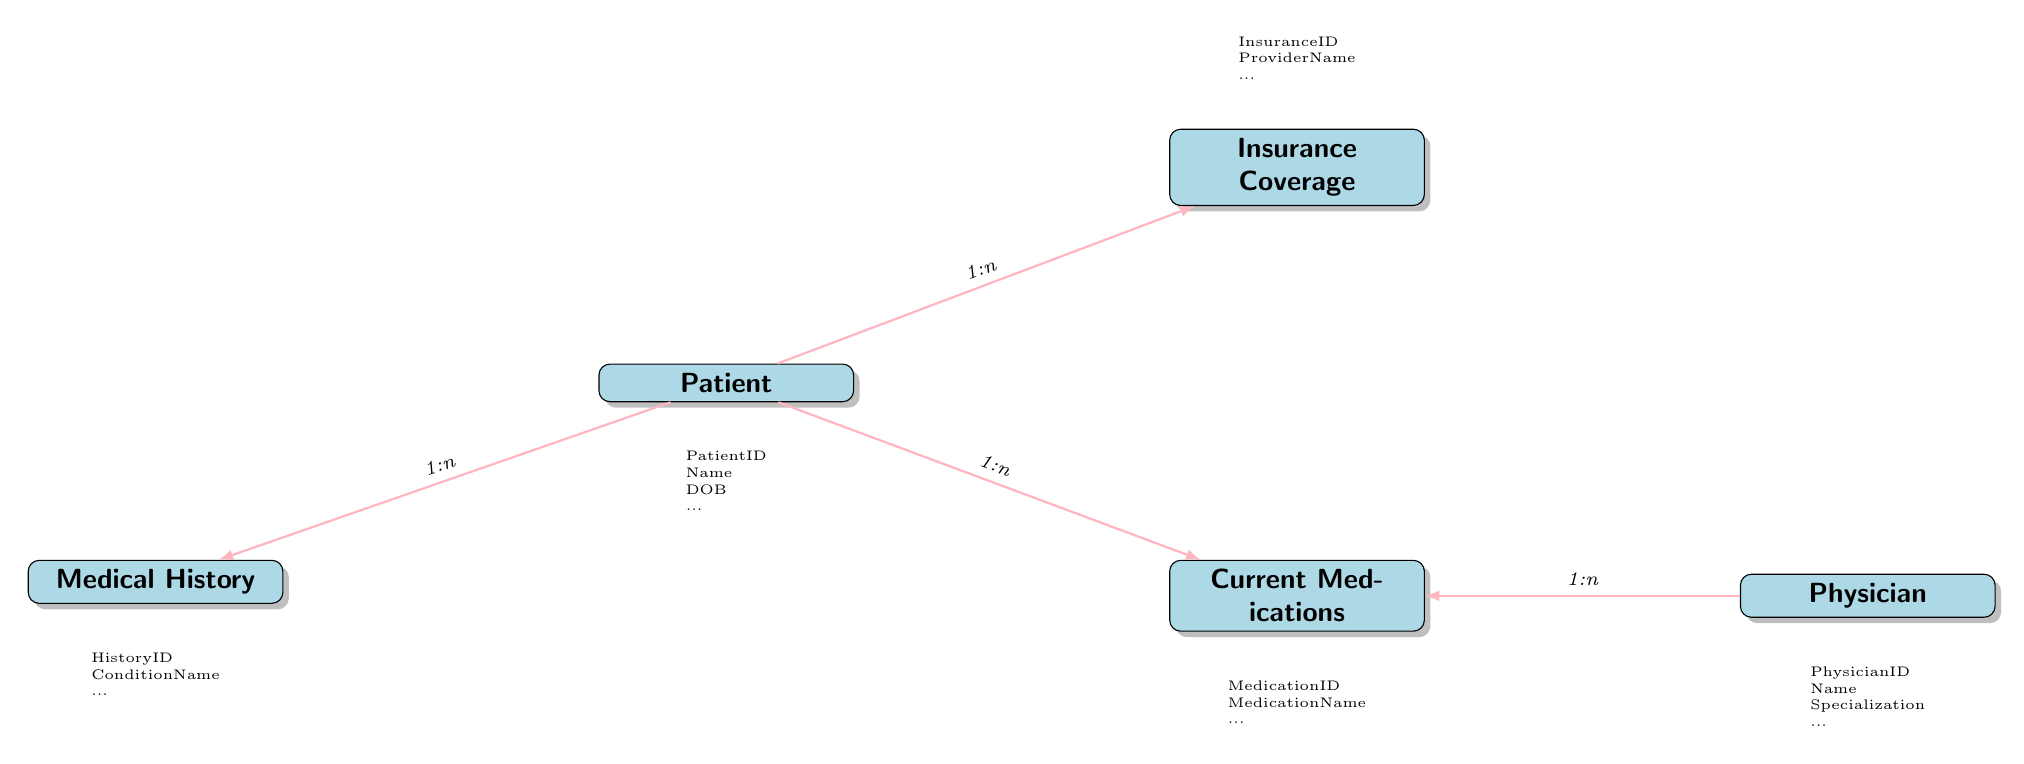What is the unique identifier for a Patient? The diagram identifies the unique identifier for a Patient as 'PatientID', which is displayed under the 'Patient' entity.
Answer: PatientID How many entities are shown in the diagram? There are five entities displayed in the diagram: Patient, Medical History, Current Medications, Insurance Coverage, and Physician.
Answer: 5 What type of relationship exists between Patient and Current Medications? The diagram indicates a '1-to-many' relationship between Patient and Current Medications, meaning one Patient may have multiple Current Medications.
Answer: 1-to-many What is the key attribute of the Current Medications entity? The key attribute for Current Medications is 'MedicationID', as it serves as a unique identifier within that entity, which can be found under the Current Medications node.
Answer: MedicationID Which entity is connected to Current Medications via the Prescribing Physician? The diagram shows that the entity 'Physician' is connected to Current Medications, indicating that one Physician can prescribe multiple Current Medications.
Answer: Physician How many Insurance Coverage records can a Patient have? According to the diagram, since there is a '1-to-many' relationship between Patient and Insurance Coverage, a Patient can have multiple Insurance Coverage records.
Answer: Many What is the role of the 'Notes' attribute in the Medical History entity? The 'Notes' attribute in the Medical History entity is used to provide additional information or comments related to a patient's medical history, which helps in understanding the patient's background better.
Answer: Additional information Which attribute identifies the Physician's specialization? The attribute that identifies a Physician’s specialization is 'Specialization', which is part of the Physician entity in the diagram.
Answer: Specialization 